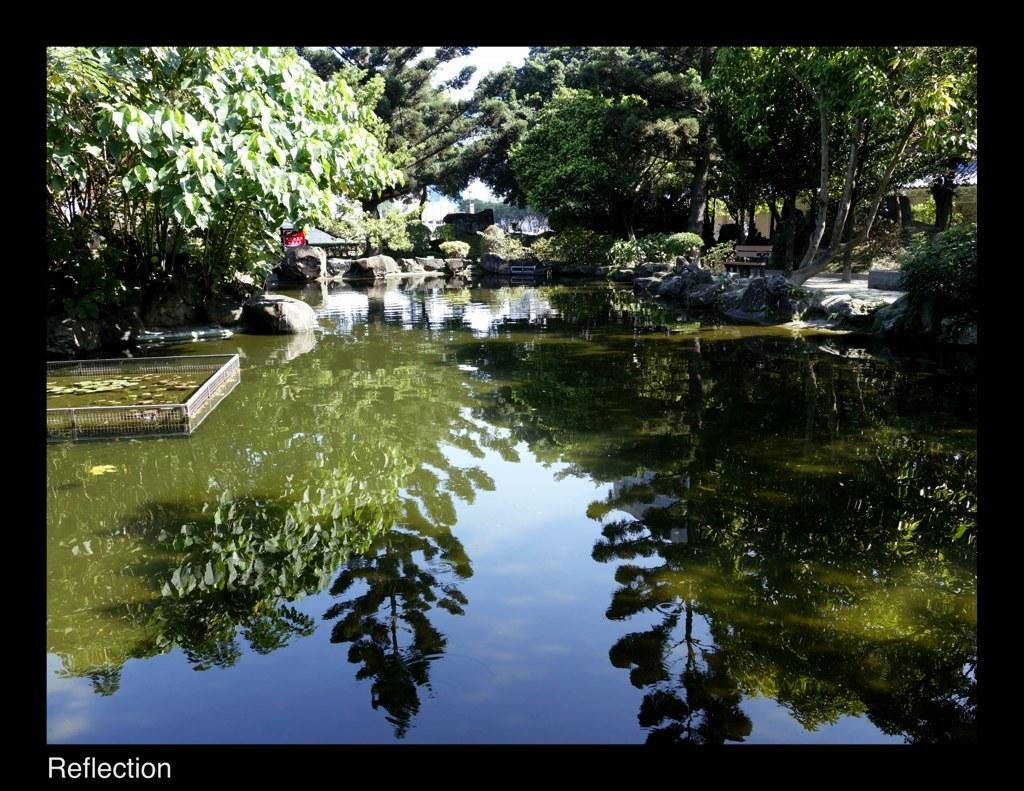What is present in the image that is not solid? There is water in the image that is not solid. What objects can be found in the water? There are no objects found in the water, but there are rocks, plants, and trees surrounding the water. What can be seen in the water's reflection? The water has a reflection in it, which likely includes the sky and surrounding objects. What type of vegetation is present in the image? There are plants and trees in the image. What type of advertisement can be seen on the rocks in the image? There is no advertisement present on the rocks in the image. Can you tell me how many bats are flying over the trees in the image? There are no bats visible in the image; it only features water, rocks, plants, trees, and a reflection. 